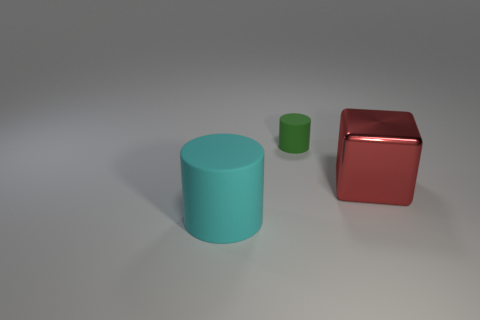What size is the other cyan matte object that is the same shape as the small thing?
Offer a very short reply. Large. Is there anything else that has the same size as the shiny block?
Make the answer very short. Yes. There is a cylinder that is behind the large cyan matte object on the left side of the matte thing that is to the right of the large cyan cylinder; what is it made of?
Offer a terse response. Rubber. Are there more rubber things that are in front of the red object than big metal objects that are on the left side of the green cylinder?
Offer a terse response. Yes. Do the red block and the green object have the same size?
Keep it short and to the point. No. There is another large thing that is the same shape as the green object; what is its color?
Ensure brevity in your answer.  Cyan. How many other things are the same color as the large matte object?
Give a very brief answer. 0. Are there more cubes that are in front of the big cylinder than small green matte things?
Provide a succinct answer. No. The rubber object behind the rubber object that is in front of the red metallic thing is what color?
Provide a succinct answer. Green. What number of things are either matte cylinders that are right of the cyan object or objects that are behind the red cube?
Offer a very short reply. 1. 